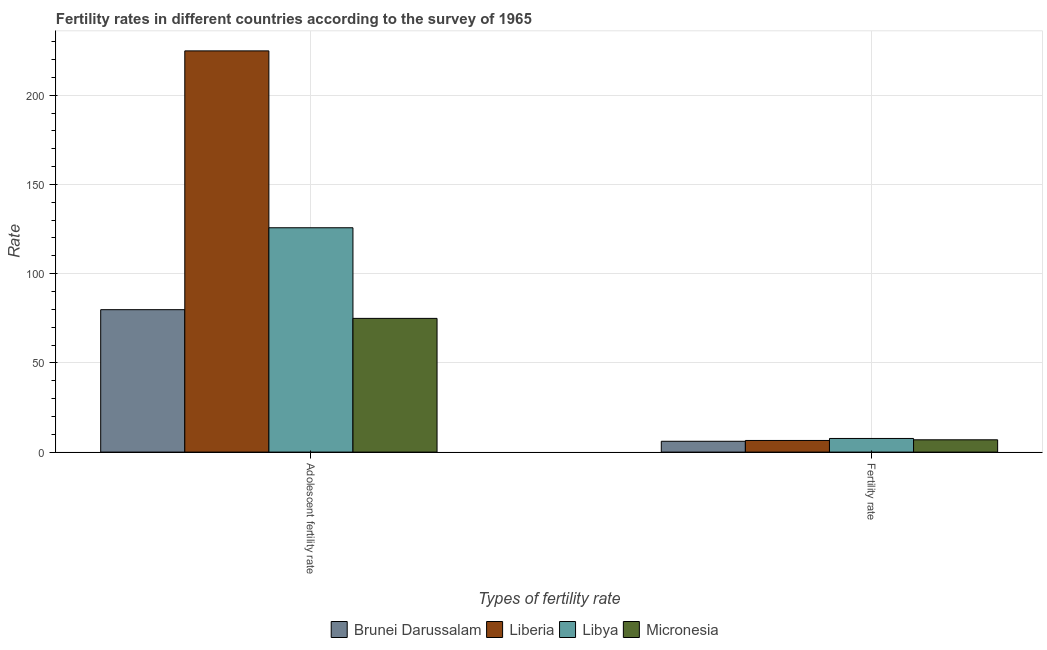How many groups of bars are there?
Provide a short and direct response. 2. Are the number of bars per tick equal to the number of legend labels?
Make the answer very short. Yes. How many bars are there on the 2nd tick from the right?
Ensure brevity in your answer.  4. What is the label of the 1st group of bars from the left?
Offer a terse response. Adolescent fertility rate. What is the adolescent fertility rate in Brunei Darussalam?
Provide a short and direct response. 79.82. Across all countries, what is the maximum adolescent fertility rate?
Offer a very short reply. 224.85. Across all countries, what is the minimum fertility rate?
Offer a very short reply. 6.07. In which country was the adolescent fertility rate maximum?
Your answer should be very brief. Liberia. In which country was the adolescent fertility rate minimum?
Provide a short and direct response. Micronesia. What is the total adolescent fertility rate in the graph?
Your answer should be compact. 505.32. What is the difference between the adolescent fertility rate in Brunei Darussalam and that in Libya?
Provide a succinct answer. -45.91. What is the difference between the adolescent fertility rate in Micronesia and the fertility rate in Liberia?
Offer a very short reply. 68.41. What is the average fertility rate per country?
Your response must be concise. 6.78. What is the difference between the fertility rate and adolescent fertility rate in Liberia?
Give a very brief answer. -218.32. In how many countries, is the adolescent fertility rate greater than 220 ?
Offer a very short reply. 1. What is the ratio of the adolescent fertility rate in Brunei Darussalam to that in Micronesia?
Make the answer very short. 1.07. Is the adolescent fertility rate in Libya less than that in Brunei Darussalam?
Ensure brevity in your answer.  No. What does the 3rd bar from the left in Fertility rate represents?
Provide a succinct answer. Libya. What does the 3rd bar from the right in Adolescent fertility rate represents?
Ensure brevity in your answer.  Liberia. Are all the bars in the graph horizontal?
Offer a terse response. No. How many countries are there in the graph?
Offer a terse response. 4. What is the difference between two consecutive major ticks on the Y-axis?
Provide a short and direct response. 50. Does the graph contain any zero values?
Give a very brief answer. No. Where does the legend appear in the graph?
Give a very brief answer. Bottom center. What is the title of the graph?
Your response must be concise. Fertility rates in different countries according to the survey of 1965. Does "Pakistan" appear as one of the legend labels in the graph?
Ensure brevity in your answer.  No. What is the label or title of the X-axis?
Give a very brief answer. Types of fertility rate. What is the label or title of the Y-axis?
Your answer should be compact. Rate. What is the Rate of Brunei Darussalam in Adolescent fertility rate?
Provide a succinct answer. 79.82. What is the Rate of Liberia in Adolescent fertility rate?
Make the answer very short. 224.85. What is the Rate in Libya in Adolescent fertility rate?
Your answer should be very brief. 125.73. What is the Rate in Micronesia in Adolescent fertility rate?
Make the answer very short. 74.93. What is the Rate of Brunei Darussalam in Fertility rate?
Give a very brief answer. 6.07. What is the Rate of Liberia in Fertility rate?
Give a very brief answer. 6.52. What is the Rate in Libya in Fertility rate?
Provide a short and direct response. 7.65. What is the Rate in Micronesia in Fertility rate?
Offer a terse response. 6.89. Across all Types of fertility rate, what is the maximum Rate of Brunei Darussalam?
Keep it short and to the point. 79.82. Across all Types of fertility rate, what is the maximum Rate in Liberia?
Give a very brief answer. 224.85. Across all Types of fertility rate, what is the maximum Rate of Libya?
Ensure brevity in your answer.  125.73. Across all Types of fertility rate, what is the maximum Rate of Micronesia?
Your answer should be compact. 74.93. Across all Types of fertility rate, what is the minimum Rate in Brunei Darussalam?
Your answer should be compact. 6.07. Across all Types of fertility rate, what is the minimum Rate in Liberia?
Offer a terse response. 6.52. Across all Types of fertility rate, what is the minimum Rate in Libya?
Offer a terse response. 7.65. Across all Types of fertility rate, what is the minimum Rate of Micronesia?
Offer a terse response. 6.89. What is the total Rate in Brunei Darussalam in the graph?
Your response must be concise. 85.88. What is the total Rate in Liberia in the graph?
Your response must be concise. 231.37. What is the total Rate of Libya in the graph?
Provide a succinct answer. 133.38. What is the total Rate in Micronesia in the graph?
Your response must be concise. 81.83. What is the difference between the Rate of Brunei Darussalam in Adolescent fertility rate and that in Fertility rate?
Provide a short and direct response. 73.75. What is the difference between the Rate of Liberia in Adolescent fertility rate and that in Fertility rate?
Ensure brevity in your answer.  218.32. What is the difference between the Rate of Libya in Adolescent fertility rate and that in Fertility rate?
Give a very brief answer. 118.08. What is the difference between the Rate of Micronesia in Adolescent fertility rate and that in Fertility rate?
Offer a terse response. 68.04. What is the difference between the Rate of Brunei Darussalam in Adolescent fertility rate and the Rate of Liberia in Fertility rate?
Your answer should be very brief. 73.29. What is the difference between the Rate of Brunei Darussalam in Adolescent fertility rate and the Rate of Libya in Fertility rate?
Your response must be concise. 72.17. What is the difference between the Rate in Brunei Darussalam in Adolescent fertility rate and the Rate in Micronesia in Fertility rate?
Offer a terse response. 72.92. What is the difference between the Rate of Liberia in Adolescent fertility rate and the Rate of Libya in Fertility rate?
Keep it short and to the point. 217.2. What is the difference between the Rate in Liberia in Adolescent fertility rate and the Rate in Micronesia in Fertility rate?
Make the answer very short. 217.95. What is the difference between the Rate of Libya in Adolescent fertility rate and the Rate of Micronesia in Fertility rate?
Give a very brief answer. 118.83. What is the average Rate of Brunei Darussalam per Types of fertility rate?
Provide a succinct answer. 42.94. What is the average Rate of Liberia per Types of fertility rate?
Ensure brevity in your answer.  115.68. What is the average Rate of Libya per Types of fertility rate?
Offer a terse response. 66.69. What is the average Rate of Micronesia per Types of fertility rate?
Make the answer very short. 40.91. What is the difference between the Rate in Brunei Darussalam and Rate in Liberia in Adolescent fertility rate?
Your answer should be very brief. -145.03. What is the difference between the Rate in Brunei Darussalam and Rate in Libya in Adolescent fertility rate?
Give a very brief answer. -45.91. What is the difference between the Rate of Brunei Darussalam and Rate of Micronesia in Adolescent fertility rate?
Offer a very short reply. 4.88. What is the difference between the Rate in Liberia and Rate in Libya in Adolescent fertility rate?
Offer a very short reply. 99.12. What is the difference between the Rate of Liberia and Rate of Micronesia in Adolescent fertility rate?
Ensure brevity in your answer.  149.91. What is the difference between the Rate of Libya and Rate of Micronesia in Adolescent fertility rate?
Provide a short and direct response. 50.79. What is the difference between the Rate of Brunei Darussalam and Rate of Liberia in Fertility rate?
Provide a short and direct response. -0.46. What is the difference between the Rate in Brunei Darussalam and Rate in Libya in Fertility rate?
Your answer should be compact. -1.58. What is the difference between the Rate in Brunei Darussalam and Rate in Micronesia in Fertility rate?
Provide a short and direct response. -0.83. What is the difference between the Rate in Liberia and Rate in Libya in Fertility rate?
Make the answer very short. -1.12. What is the difference between the Rate in Liberia and Rate in Micronesia in Fertility rate?
Your answer should be compact. -0.37. What is the difference between the Rate of Libya and Rate of Micronesia in Fertility rate?
Ensure brevity in your answer.  0.75. What is the ratio of the Rate of Brunei Darussalam in Adolescent fertility rate to that in Fertility rate?
Offer a terse response. 13.15. What is the ratio of the Rate in Liberia in Adolescent fertility rate to that in Fertility rate?
Ensure brevity in your answer.  34.46. What is the ratio of the Rate in Libya in Adolescent fertility rate to that in Fertility rate?
Offer a terse response. 16.44. What is the ratio of the Rate in Micronesia in Adolescent fertility rate to that in Fertility rate?
Make the answer very short. 10.87. What is the difference between the highest and the second highest Rate of Brunei Darussalam?
Provide a short and direct response. 73.75. What is the difference between the highest and the second highest Rate of Liberia?
Provide a succinct answer. 218.32. What is the difference between the highest and the second highest Rate of Libya?
Make the answer very short. 118.08. What is the difference between the highest and the second highest Rate of Micronesia?
Keep it short and to the point. 68.04. What is the difference between the highest and the lowest Rate in Brunei Darussalam?
Ensure brevity in your answer.  73.75. What is the difference between the highest and the lowest Rate in Liberia?
Keep it short and to the point. 218.32. What is the difference between the highest and the lowest Rate in Libya?
Make the answer very short. 118.08. What is the difference between the highest and the lowest Rate of Micronesia?
Your answer should be compact. 68.04. 